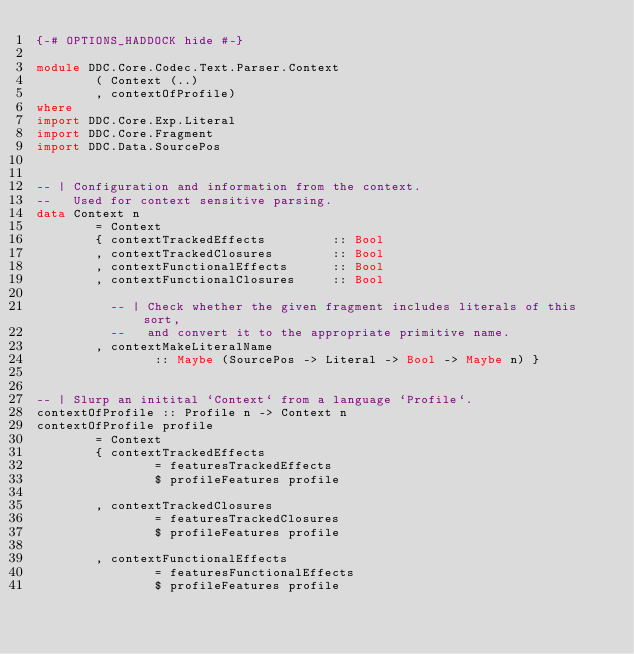Convert code to text. <code><loc_0><loc_0><loc_500><loc_500><_Haskell_>{-# OPTIONS_HADDOCK hide #-}

module DDC.Core.Codec.Text.Parser.Context
        ( Context (..)
        , contextOfProfile)
where
import DDC.Core.Exp.Literal
import DDC.Core.Fragment
import DDC.Data.SourcePos


-- | Configuration and information from the context.
--   Used for context sensitive parsing.
data Context n
        = Context
        { contextTrackedEffects         :: Bool
        , contextTrackedClosures        :: Bool
        , contextFunctionalEffects      :: Bool
        , contextFunctionalClosures     :: Bool

          -- | Check whether the given fragment includes literals of this sort,
          --   and convert it to the appropriate primitive name.
        , contextMakeLiteralName
                :: Maybe (SourcePos -> Literal -> Bool -> Maybe n) }


-- | Slurp an initital `Context` from a language `Profile`.
contextOfProfile :: Profile n -> Context n
contextOfProfile profile
        = Context
        { contextTrackedEffects
                = featuresTrackedEffects
                $ profileFeatures profile

        , contextTrackedClosures
                = featuresTrackedClosures
                $ profileFeatures profile

        , contextFunctionalEffects
                = featuresFunctionalEffects
                $ profileFeatures profile
</code> 